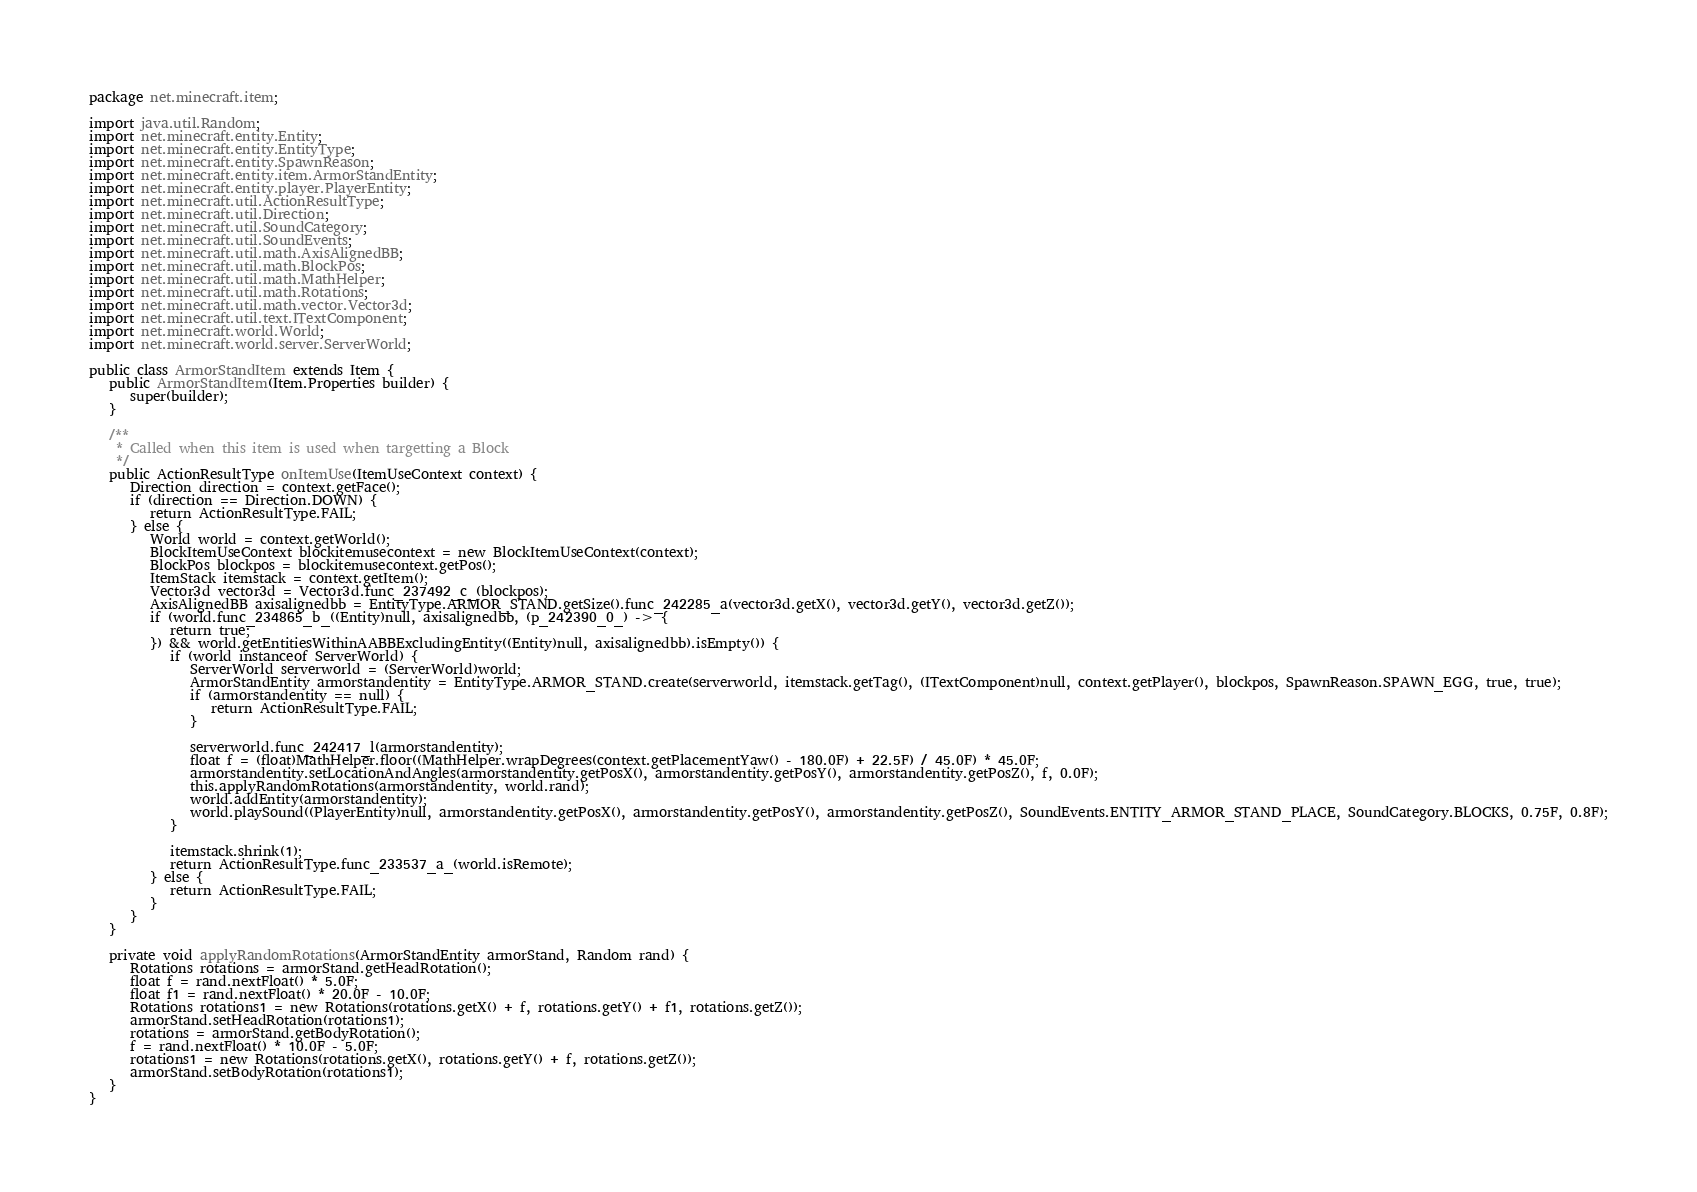<code> <loc_0><loc_0><loc_500><loc_500><_Java_>package net.minecraft.item;

import java.util.Random;
import net.minecraft.entity.Entity;
import net.minecraft.entity.EntityType;
import net.minecraft.entity.SpawnReason;
import net.minecraft.entity.item.ArmorStandEntity;
import net.minecraft.entity.player.PlayerEntity;
import net.minecraft.util.ActionResultType;
import net.minecraft.util.Direction;
import net.minecraft.util.SoundCategory;
import net.minecraft.util.SoundEvents;
import net.minecraft.util.math.AxisAlignedBB;
import net.minecraft.util.math.BlockPos;
import net.minecraft.util.math.MathHelper;
import net.minecraft.util.math.Rotations;
import net.minecraft.util.math.vector.Vector3d;
import net.minecraft.util.text.ITextComponent;
import net.minecraft.world.World;
import net.minecraft.world.server.ServerWorld;

public class ArmorStandItem extends Item {
   public ArmorStandItem(Item.Properties builder) {
      super(builder);
   }

   /**
    * Called when this item is used when targetting a Block
    */
   public ActionResultType onItemUse(ItemUseContext context) {
      Direction direction = context.getFace();
      if (direction == Direction.DOWN) {
         return ActionResultType.FAIL;
      } else {
         World world = context.getWorld();
         BlockItemUseContext blockitemusecontext = new BlockItemUseContext(context);
         BlockPos blockpos = blockitemusecontext.getPos();
         ItemStack itemstack = context.getItem();
         Vector3d vector3d = Vector3d.func_237492_c_(blockpos);
         AxisAlignedBB axisalignedbb = EntityType.ARMOR_STAND.getSize().func_242285_a(vector3d.getX(), vector3d.getY(), vector3d.getZ());
         if (world.func_234865_b_((Entity)null, axisalignedbb, (p_242390_0_) -> {
            return true;
         }) && world.getEntitiesWithinAABBExcludingEntity((Entity)null, axisalignedbb).isEmpty()) {
            if (world instanceof ServerWorld) {
               ServerWorld serverworld = (ServerWorld)world;
               ArmorStandEntity armorstandentity = EntityType.ARMOR_STAND.create(serverworld, itemstack.getTag(), (ITextComponent)null, context.getPlayer(), blockpos, SpawnReason.SPAWN_EGG, true, true);
               if (armorstandentity == null) {
                  return ActionResultType.FAIL;
               }

               serverworld.func_242417_l(armorstandentity);
               float f = (float)MathHelper.floor((MathHelper.wrapDegrees(context.getPlacementYaw() - 180.0F) + 22.5F) / 45.0F) * 45.0F;
               armorstandentity.setLocationAndAngles(armorstandentity.getPosX(), armorstandentity.getPosY(), armorstandentity.getPosZ(), f, 0.0F);
               this.applyRandomRotations(armorstandentity, world.rand);
               world.addEntity(armorstandentity);
               world.playSound((PlayerEntity)null, armorstandentity.getPosX(), armorstandentity.getPosY(), armorstandentity.getPosZ(), SoundEvents.ENTITY_ARMOR_STAND_PLACE, SoundCategory.BLOCKS, 0.75F, 0.8F);
            }

            itemstack.shrink(1);
            return ActionResultType.func_233537_a_(world.isRemote);
         } else {
            return ActionResultType.FAIL;
         }
      }
   }

   private void applyRandomRotations(ArmorStandEntity armorStand, Random rand) {
      Rotations rotations = armorStand.getHeadRotation();
      float f = rand.nextFloat() * 5.0F;
      float f1 = rand.nextFloat() * 20.0F - 10.0F;
      Rotations rotations1 = new Rotations(rotations.getX() + f, rotations.getY() + f1, rotations.getZ());
      armorStand.setHeadRotation(rotations1);
      rotations = armorStand.getBodyRotation();
      f = rand.nextFloat() * 10.0F - 5.0F;
      rotations1 = new Rotations(rotations.getX(), rotations.getY() + f, rotations.getZ());
      armorStand.setBodyRotation(rotations1);
   }
}</code> 